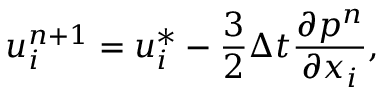Convert formula to latex. <formula><loc_0><loc_0><loc_500><loc_500>u _ { i } ^ { n + 1 } = u _ { i } ^ { * } - \frac { 3 } { 2 } \Delta t \frac { \partial p ^ { n } } { \partial x _ { i } } ,</formula> 